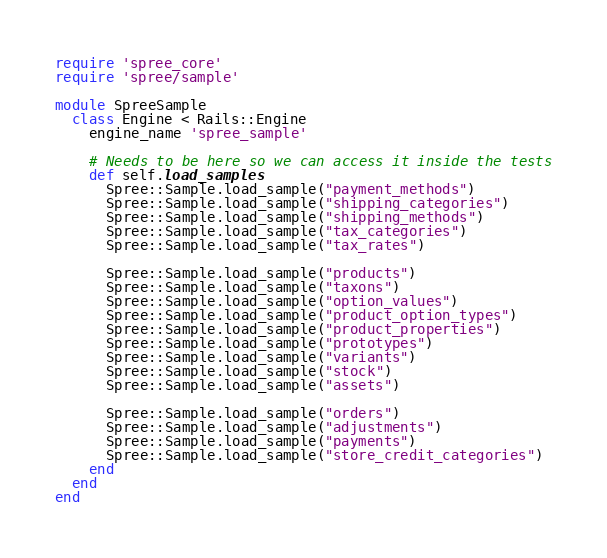<code> <loc_0><loc_0><loc_500><loc_500><_Ruby_>require 'spree_core'
require 'spree/sample'

module SpreeSample
  class Engine < Rails::Engine
    engine_name 'spree_sample'

    # Needs to be here so we can access it inside the tests
    def self.load_samples
      Spree::Sample.load_sample("payment_methods")
      Spree::Sample.load_sample("shipping_categories")
      Spree::Sample.load_sample("shipping_methods")
      Spree::Sample.load_sample("tax_categories")
      Spree::Sample.load_sample("tax_rates")

      Spree::Sample.load_sample("products")
      Spree::Sample.load_sample("taxons")
      Spree::Sample.load_sample("option_values")
      Spree::Sample.load_sample("product_option_types")
      Spree::Sample.load_sample("product_properties")
      Spree::Sample.load_sample("prototypes")
      Spree::Sample.load_sample("variants")
      Spree::Sample.load_sample("stock")
      Spree::Sample.load_sample("assets")

      Spree::Sample.load_sample("orders")
      Spree::Sample.load_sample("adjustments")
      Spree::Sample.load_sample("payments")
      Spree::Sample.load_sample("store_credit_categories")
    end
  end
end
</code> 